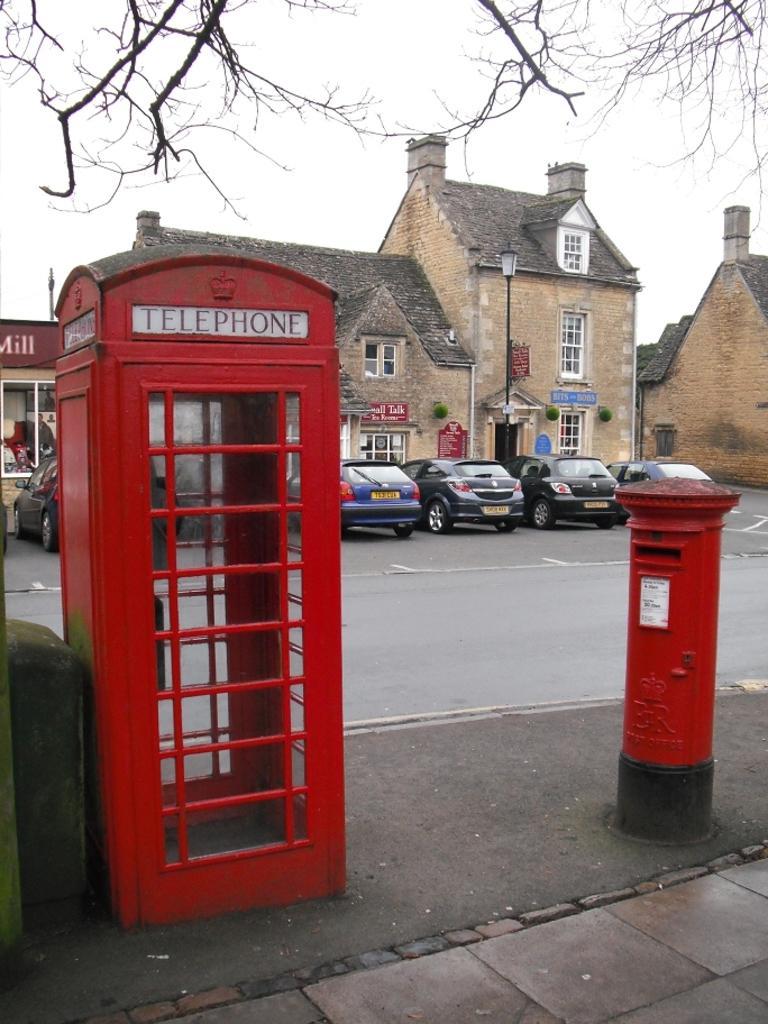How would you summarize this image in a sentence or two? In this picture there is a telephone booth near to the wall. Beside that there is a post box. In the back I can see the cars which are parked near to the buildings. On the right there is a street light near to the board. Behind the cars there is a road. At the top I can see the tree and sky. 